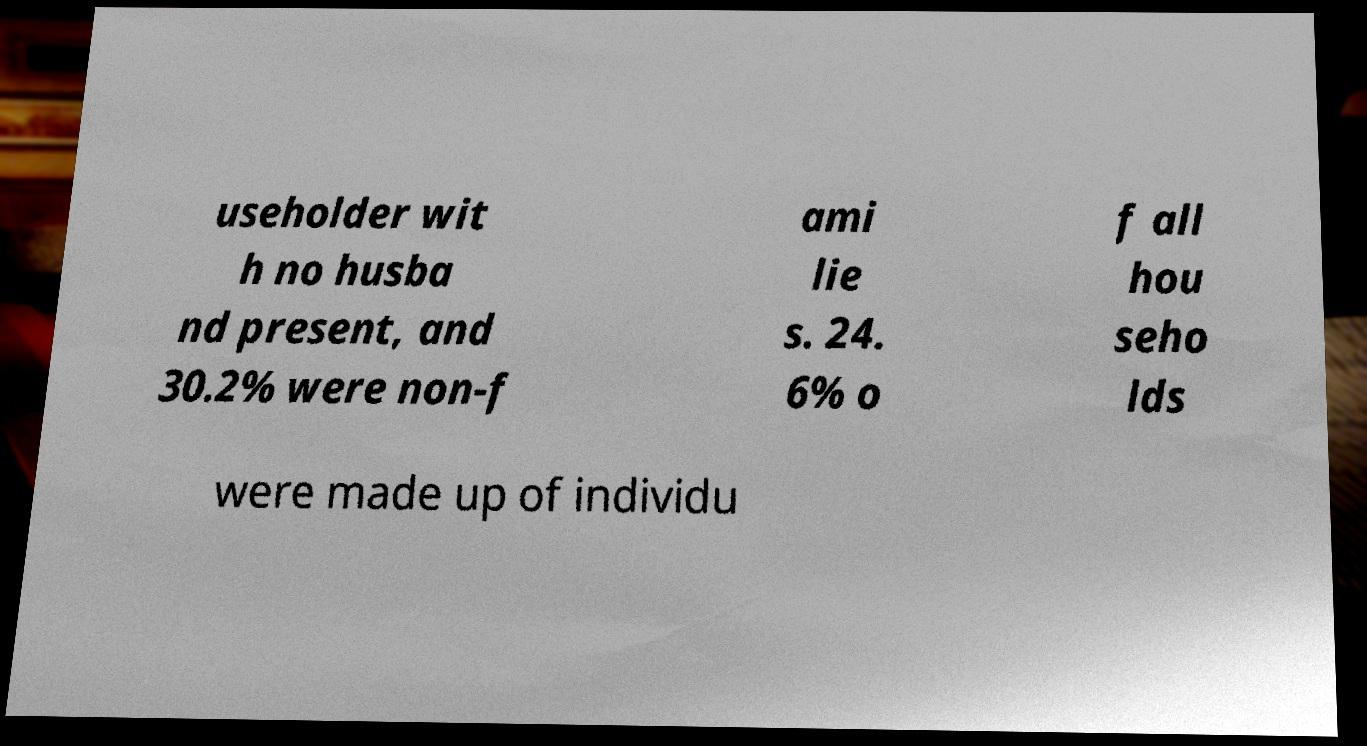Please identify and transcribe the text found in this image. useholder wit h no husba nd present, and 30.2% were non-f ami lie s. 24. 6% o f all hou seho lds were made up of individu 